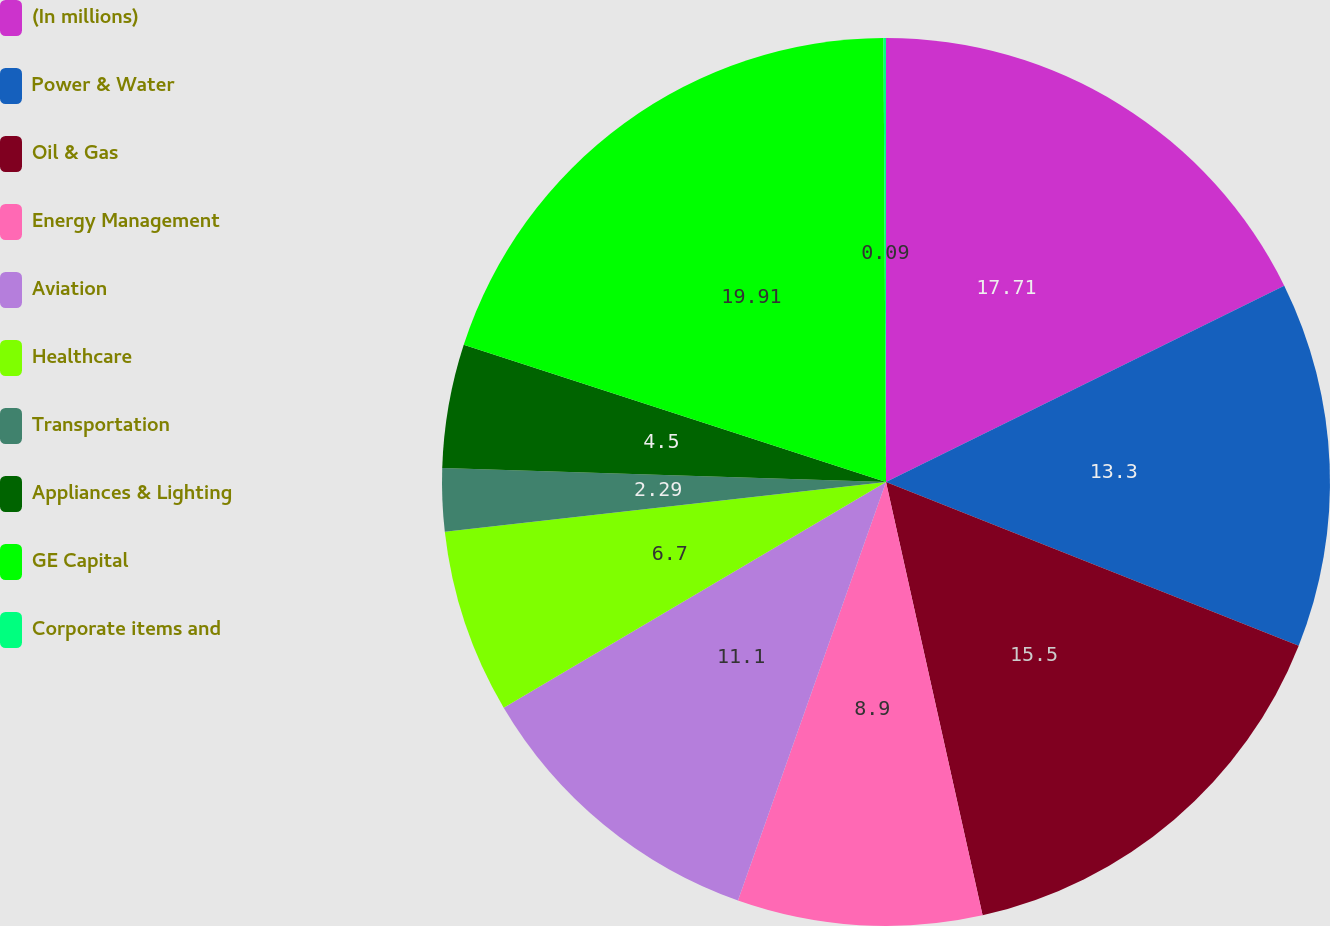Convert chart. <chart><loc_0><loc_0><loc_500><loc_500><pie_chart><fcel>(In millions)<fcel>Power & Water<fcel>Oil & Gas<fcel>Energy Management<fcel>Aviation<fcel>Healthcare<fcel>Transportation<fcel>Appliances & Lighting<fcel>GE Capital<fcel>Corporate items and<nl><fcel>17.71%<fcel>13.3%<fcel>15.5%<fcel>8.9%<fcel>11.1%<fcel>6.7%<fcel>2.29%<fcel>4.5%<fcel>19.91%<fcel>0.09%<nl></chart> 